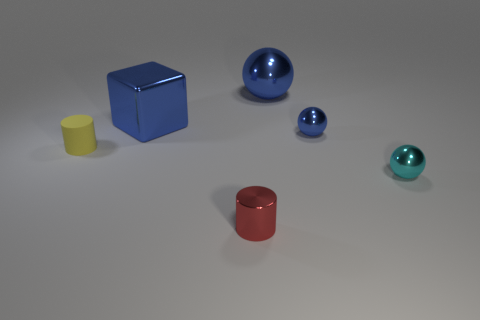Add 3 blue spheres. How many objects exist? 9 Subtract all blocks. How many objects are left? 5 Subtract 0 brown cylinders. How many objects are left? 6 Subtract all small shiny things. Subtract all large things. How many objects are left? 1 Add 3 tiny cyan spheres. How many tiny cyan spheres are left? 4 Add 4 big red matte balls. How many big red matte balls exist? 4 